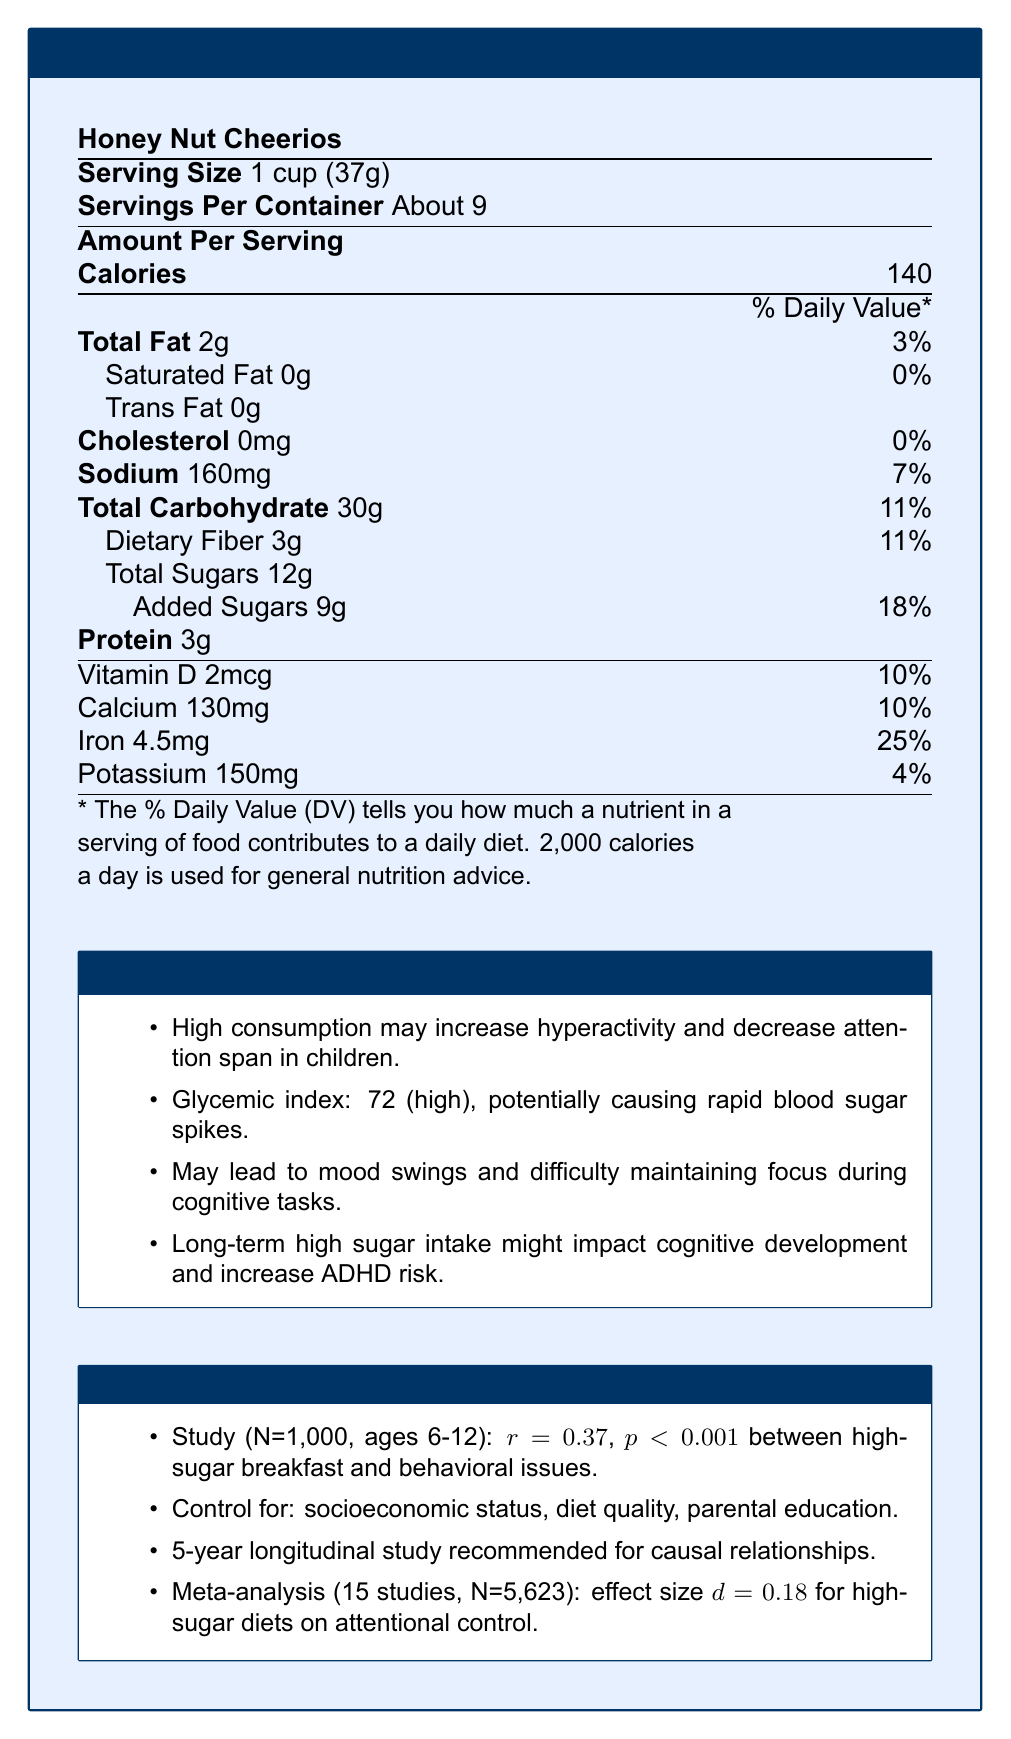what is the serving size of Honey Nut Cheerios? The serving size is clearly stated in the label as "1 cup (37g)".
Answer: 1 cup (37g) how many servings are in the container? The document mentions "Servings Per Container: About 9".
Answer: About 9 how much added sugar is there per serving and what is its daily value percentage? The label states "Added Sugars: 9g, 18%".
Answer: 9g, 18% what is the glycemic index of Honey Nut Cheerios, and how might it affect children? The psychological impact section states that Honey Nut Cheerios has a glycemic index of 72, which can cause rapid spikes in blood sugar levels.
Answer: 72, which is considered high and may lead to rapid spikes in blood sugar levels. how long is the recommended longitudinal study to investigate the relationship between sugar consumption and behavioral outcomes? The statistical considerations section mentions the recommendation of a "5-year longitudinal study" to investigate causal relationships.
Answer: 5 years how much total carbohydrate is in one serving? The document lists "Total Carbohydrate" as 30g per serving.
Answer: 30g which nutrient has the highest daily value percentage in Honey Nut Cheerios? A. Vitamin D B. Calcium C. Iron D. Sodium The nutrient Iron has the highest daily value percentage at 25%.
Answer: C. Iron what is the amount of protein per serving? A. 2g B. 3g C. 4g D. 5g The label states "Protein: 3g".
Answer: B. 3g does the cereal contain any trans fat? The label indicates "Trans Fat: 0g".
Answer: No describe the psychological impact of added sugars on children's behavior as stated in the document. The document lists several psychological impacts under the section titled "Psychological Impact of Added Sugars", noting behaviors such as hyperactivity, decreased attention, mood swings, focus issues, and potential long-term cognitive development impacts.
Answer: High consumption of added sugars may increase hyperactivity, decrease attention span, cause mood swings, and difficulty maintaining focus, and long-term high sugar intake could impact cognitive development and increase ADHD risk. what is the main idea of the document? The document presents a comprehensive view of the nutritional content, the psychological and behavioral effects of the cereal's sugar content, and relevant statistical information for understanding these effects.
Answer: The document provides nutritional information for Honey Nut Cheerios, including serving size, nutrient content, and the psychological and behavioral impacts of added sugars, supported by statistical considerations for research. how much dietary fiber is there per serving? The label mentions "Dietary Fiber: 3g" per serving.
Answer: 3g what is the correlation coefficient between high-sugar breakfast and behavioral issues in school, according to a study mentioned in the document? The statistical considerations section states a positive correlation (r = 0.37) between high-sugar breakfast consumption and behavioral issues in school.
Answer: r = 0.37 what is the impact of chronic high sugar intake during childhood, as mentioned in the document? The psychological impact section mentions long-term effects including potential impacts on cognitive development and increased ADHD risk.
Answer: It may impact cognitive development and increase the risk of attention deficit disorders. can you determine the exact socioeconomic status of the children in the study? The document mentions the need to control for socioeconomic status but does not provide specific details about it.
Answer: Cannot be determined 